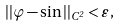Convert formula to latex. <formula><loc_0><loc_0><loc_500><loc_500>| | \varphi - \sin | | _ { C ^ { 2 } } < \varepsilon ,</formula> 